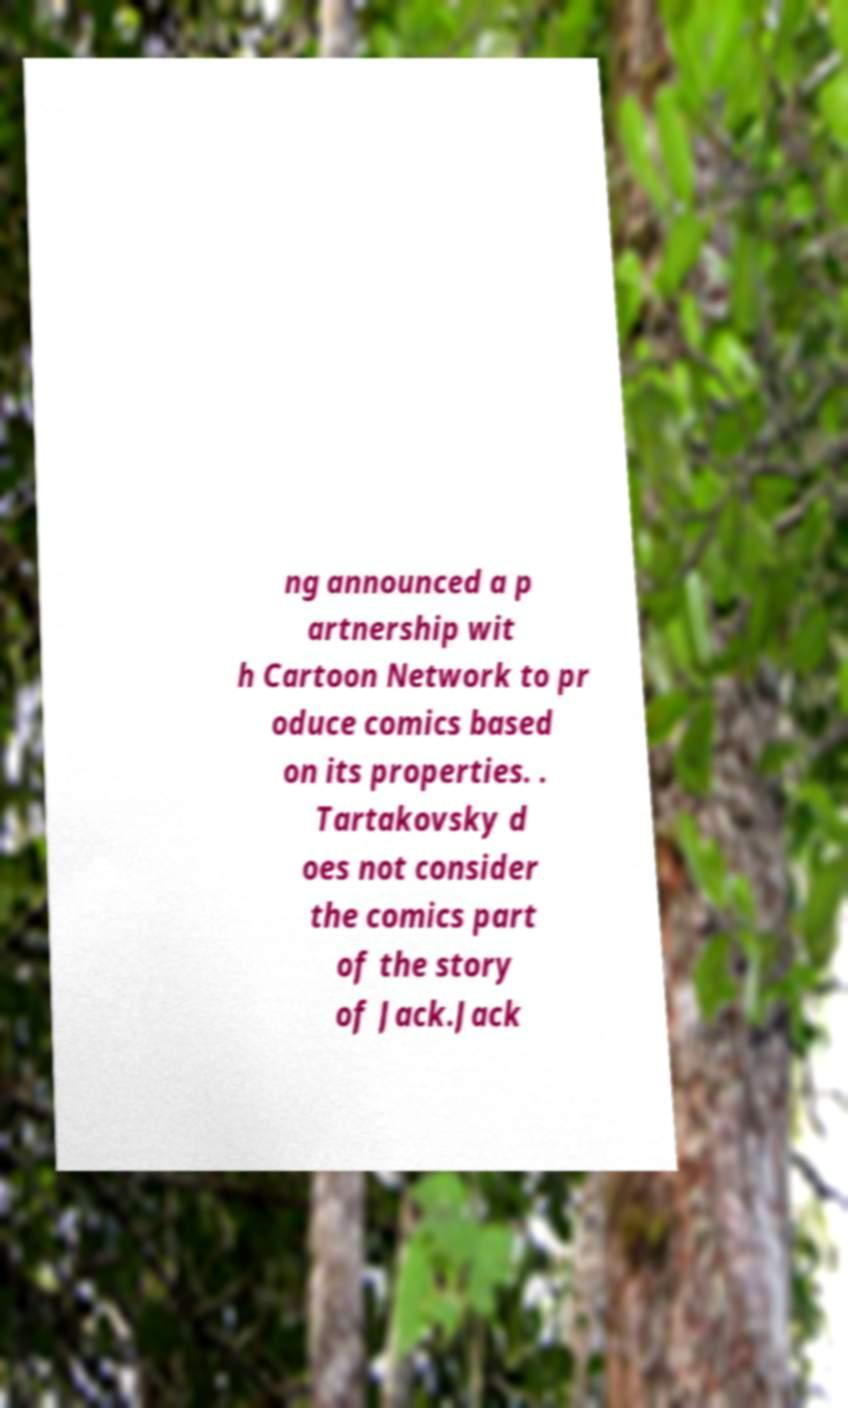I need the written content from this picture converted into text. Can you do that? ng announced a p artnership wit h Cartoon Network to pr oduce comics based on its properties. . Tartakovsky d oes not consider the comics part of the story of Jack.Jack 